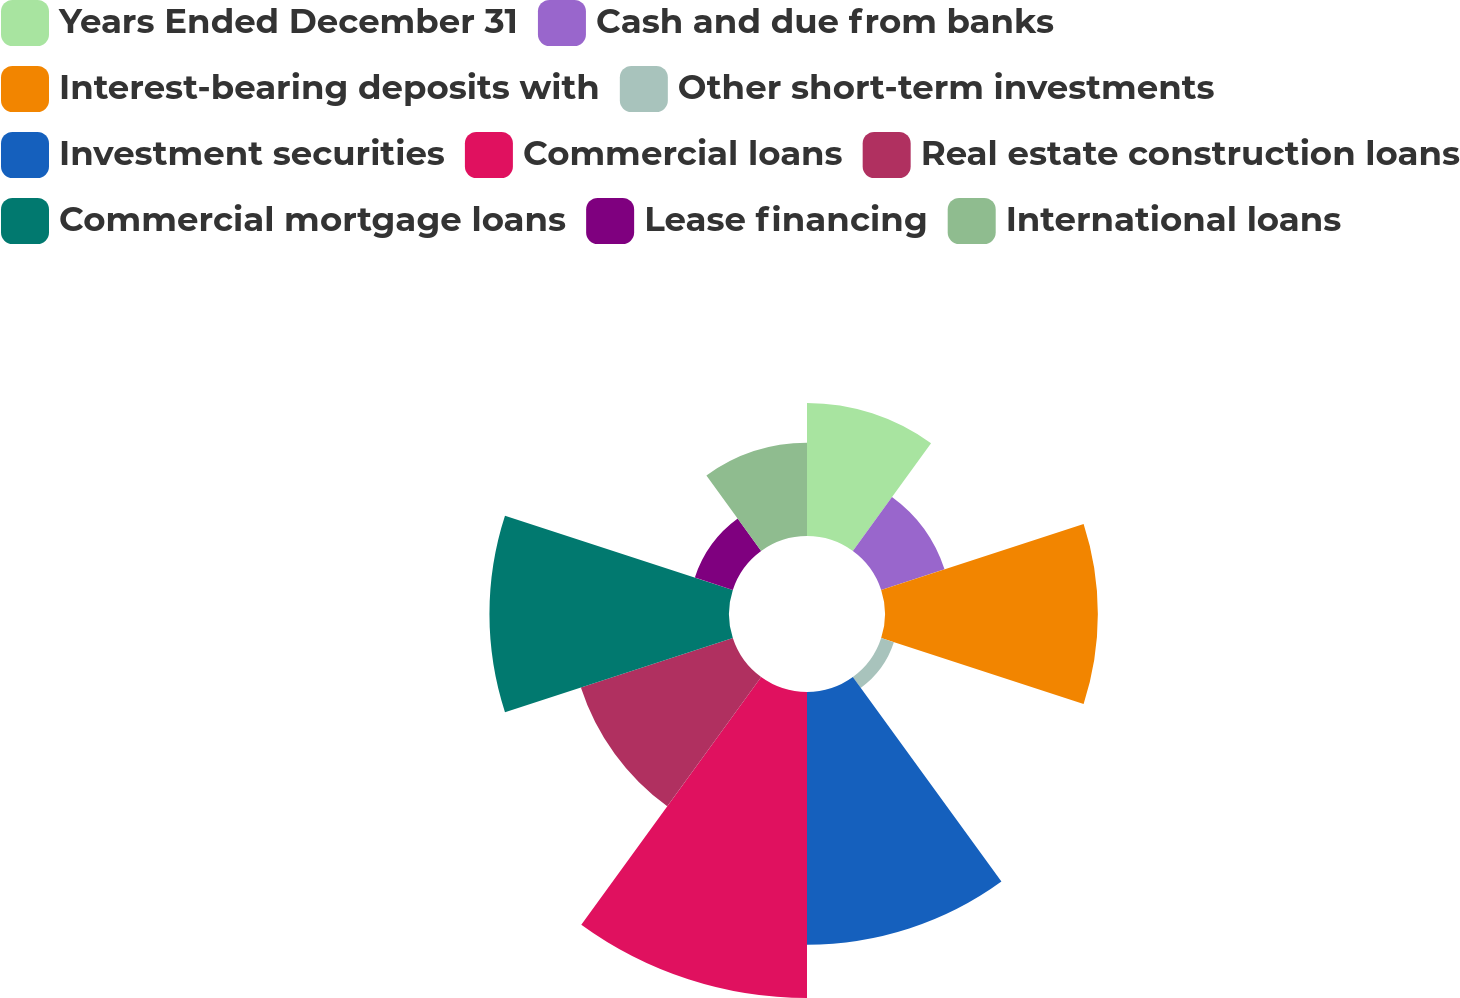<chart> <loc_0><loc_0><loc_500><loc_500><pie_chart><fcel>Years Ended December 31<fcel>Cash and due from banks<fcel>Interest-bearing deposits with<fcel>Other short-term investments<fcel>Investment securities<fcel>Commercial loans<fcel>Real estate construction loans<fcel>Commercial mortgage loans<fcel>Lease financing<fcel>International loans<nl><fcel>8.77%<fcel>4.39%<fcel>14.03%<fcel>0.88%<fcel>16.66%<fcel>20.17%<fcel>10.53%<fcel>15.79%<fcel>2.63%<fcel>6.14%<nl></chart> 